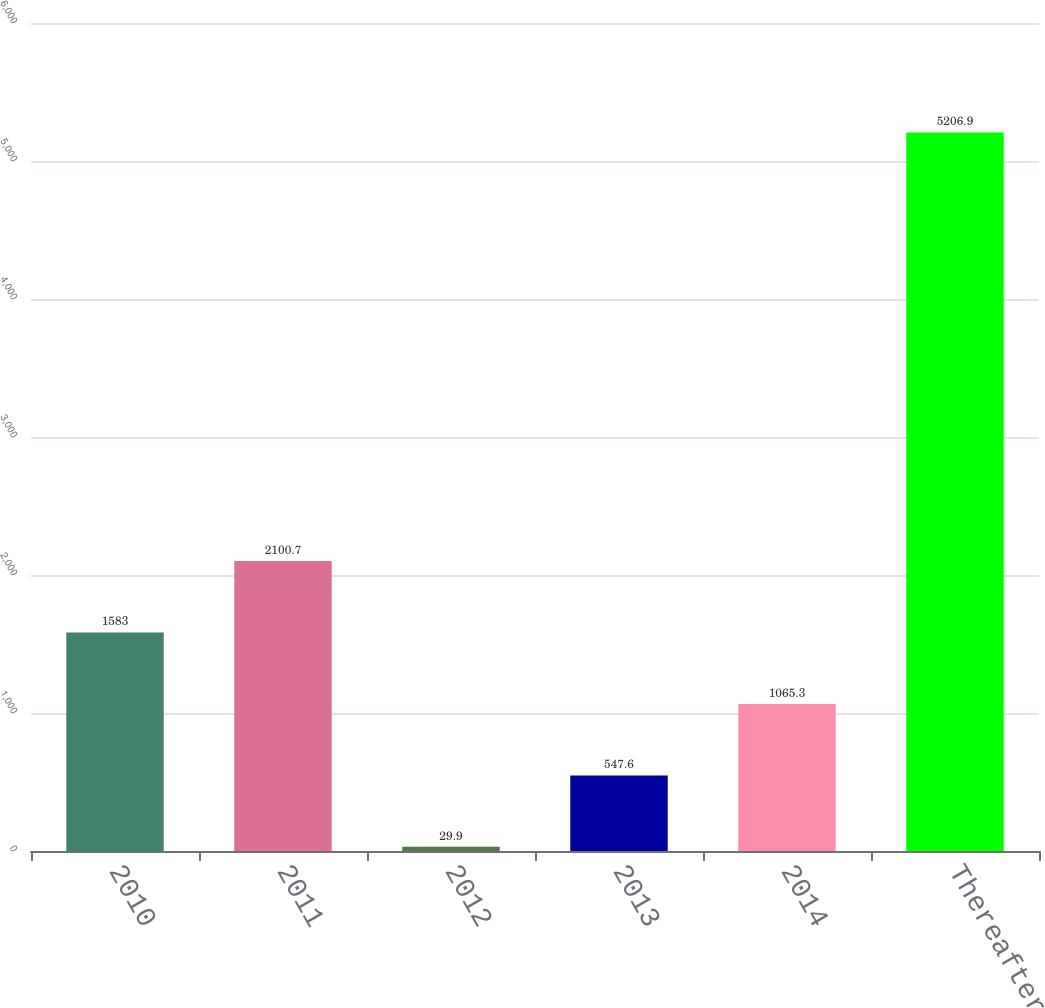Convert chart to OTSL. <chart><loc_0><loc_0><loc_500><loc_500><bar_chart><fcel>2010<fcel>2011<fcel>2012<fcel>2013<fcel>2014<fcel>Thereafter<nl><fcel>1583<fcel>2100.7<fcel>29.9<fcel>547.6<fcel>1065.3<fcel>5206.9<nl></chart> 